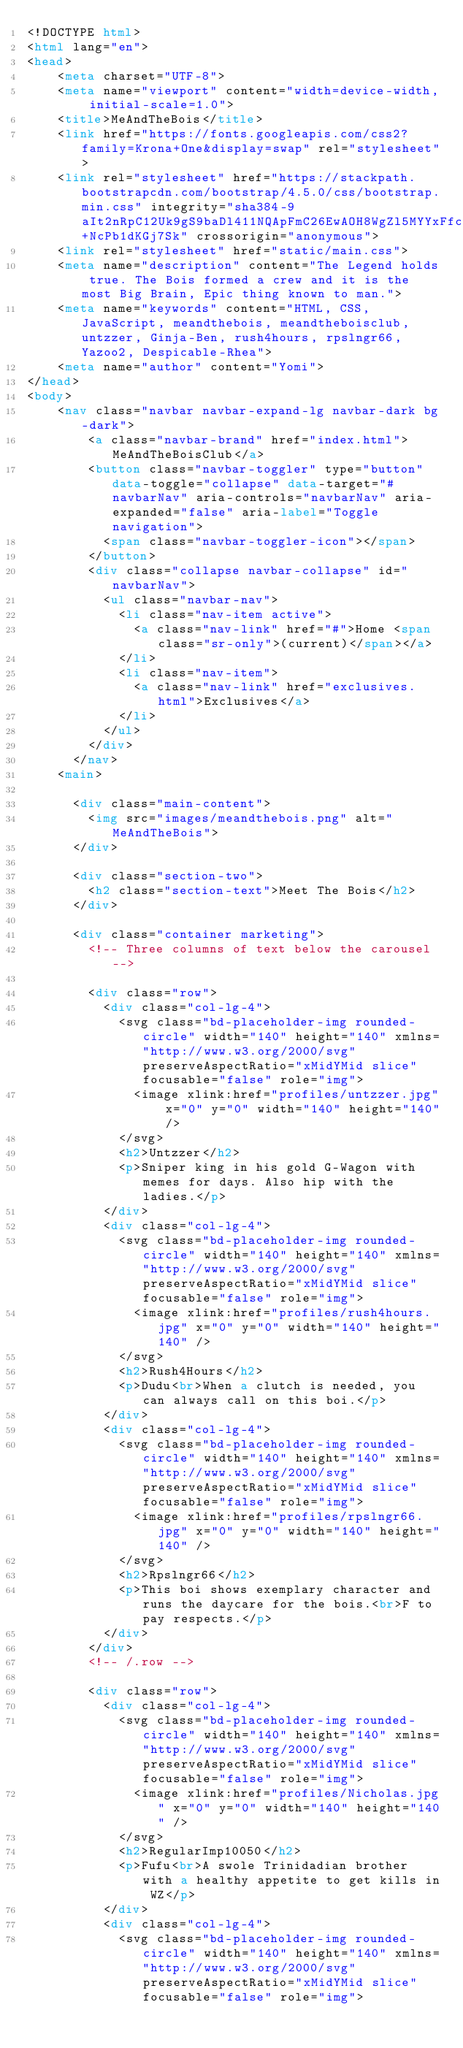<code> <loc_0><loc_0><loc_500><loc_500><_HTML_><!DOCTYPE html>
<html lang="en">
<head>
    <meta charset="UTF-8">
    <meta name="viewport" content="width=device-width, initial-scale=1.0">
    <title>MeAndTheBois</title>
    <link href="https://fonts.googleapis.com/css2?family=Krona+One&display=swap" rel="stylesheet">
    <link rel="stylesheet" href="https://stackpath.bootstrapcdn.com/bootstrap/4.5.0/css/bootstrap.min.css" integrity="sha384-9aIt2nRpC12Uk9gS9baDl411NQApFmC26EwAOH8WgZl5MYYxFfc+NcPb1dKGj7Sk" crossorigin="anonymous">
    <link rel="stylesheet" href="static/main.css">
    <meta name="description" content="The Legend holds true. The Bois formed a crew and it is the most Big Brain, Epic thing known to man.">
    <meta name="keywords" content="HTML, CSS, JavaScript, meandthebois, meandtheboisclub, untzzer, Ginja-Ben, rush4hours, rpslngr66, Yazoo2, Despicable-Rhea">
    <meta name="author" content="Yomi">
</head>
<body>
    <nav class="navbar navbar-expand-lg navbar-dark bg-dark">
        <a class="navbar-brand" href="index.html">MeAndTheBoisClub</a>
        <button class="navbar-toggler" type="button" data-toggle="collapse" data-target="#navbarNav" aria-controls="navbarNav" aria-expanded="false" aria-label="Toggle navigation">
          <span class="navbar-toggler-icon"></span>
        </button>
        <div class="collapse navbar-collapse" id="navbarNav">
          <ul class="navbar-nav">
            <li class="nav-item active">
              <a class="nav-link" href="#">Home <span class="sr-only">(current)</span></a>
            </li>
            <li class="nav-item">
              <a class="nav-link" href="exclusives.html">Exclusives</a>
            </li>
          </ul>
        </div>
      </nav>
    <main>

      <div class="main-content">
        <img src="images/meandthebois.png" alt="MeAndTheBois">
      </div>

      <div class="section-two">
        <h2 class="section-text">Meet The Bois</h2>
      </div>

      <div class="container marketing">
        <!-- Three columns of text below the carousel -->

        <div class="row">
          <div class="col-lg-4">
            <svg class="bd-placeholder-img rounded-circle" width="140" height="140" xmlns="http://www.w3.org/2000/svg" preserveAspectRatio="xMidYMid slice" focusable="false" role="img">
              <image xlink:href="profiles/untzzer.jpg" x="0" y="0" width="140" height="140" />
            </svg>
            <h2>Untzzer</h2>
            <p>Sniper king in his gold G-Wagon with memes for days. Also hip with the ladies.</p>
          </div>
          <div class="col-lg-4">
            <svg class="bd-placeholder-img rounded-circle" width="140" height="140" xmlns="http://www.w3.org/2000/svg" preserveAspectRatio="xMidYMid slice" focusable="false" role="img">
              <image xlink:href="profiles/rush4hours.jpg" x="0" y="0" width="140" height="140" />
            </svg>
            <h2>Rush4Hours</h2>
            <p>Dudu<br>When a clutch is needed, you can always call on this boi.</p>
          </div>
          <div class="col-lg-4">
            <svg class="bd-placeholder-img rounded-circle" width="140" height="140" xmlns="http://www.w3.org/2000/svg" preserveAspectRatio="xMidYMid slice" focusable="false" role="img">
              <image xlink:href="profiles/rpslngr66.jpg" x="0" y="0" width="140" height="140" />
            </svg>
            <h2>Rpslngr66</h2>
            <p>This boi shows exemplary character and runs the daycare for the bois.<br>F to pay respects.</p>
          </div>
        </div>
        <!-- /.row -->
    
        <div class="row">
          <div class="col-lg-4">
            <svg class="bd-placeholder-img rounded-circle" width="140" height="140" xmlns="http://www.w3.org/2000/svg" preserveAspectRatio="xMidYMid slice" focusable="false" role="img">
              <image xlink:href="profiles/Nicholas.jpg" x="0" y="0" width="140" height="140" />
            </svg>
            <h2>RegularImp10050</h2>
            <p>Fufu<br>A swole Trinidadian brother with a healthy appetite to get kills in WZ</p>
          </div>
          <div class="col-lg-4">
            <svg class="bd-placeholder-img rounded-circle" width="140" height="140" xmlns="http://www.w3.org/2000/svg" preserveAspectRatio="xMidYMid slice" focusable="false" role="img"></code> 